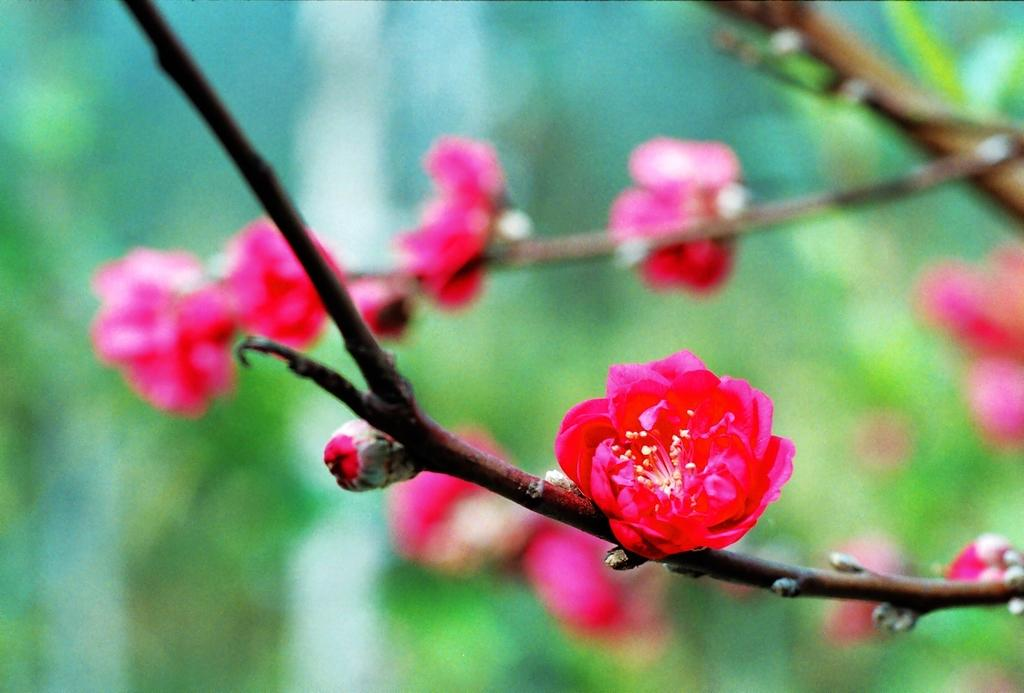What type of flowers are present in the image? There are pink color flowers in the image. Can you describe the background of the image? The background of the image is blurred. Is there a print of a low hook visible in the image? There is no print or hook present in the image; it only features pink color flowers and a blurred background. 